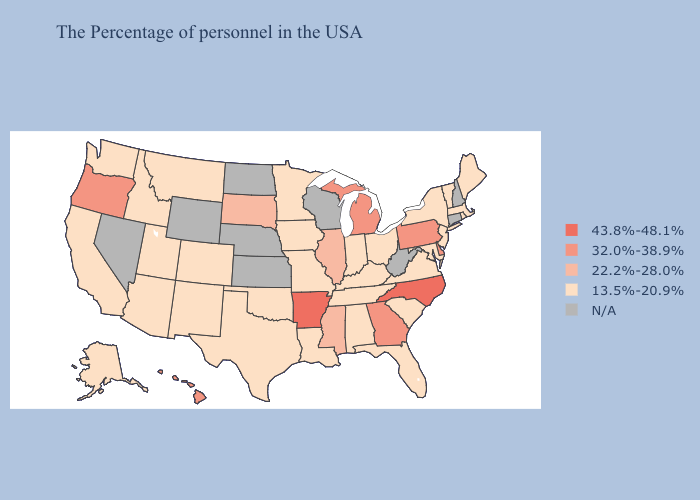Name the states that have a value in the range 43.8%-48.1%?
Write a very short answer. North Carolina, Arkansas. Does Hawaii have the highest value in the West?
Concise answer only. Yes. Does Idaho have the lowest value in the West?
Be succinct. Yes. What is the highest value in the USA?
Keep it brief. 43.8%-48.1%. What is the value of Montana?
Concise answer only. 13.5%-20.9%. What is the value of Maryland?
Be succinct. 13.5%-20.9%. What is the value of Louisiana?
Short answer required. 13.5%-20.9%. Does North Carolina have the lowest value in the South?
Give a very brief answer. No. Among the states that border New York , which have the lowest value?
Quick response, please. Massachusetts, Vermont, New Jersey. Is the legend a continuous bar?
Concise answer only. No. How many symbols are there in the legend?
Quick response, please. 5. Which states hav the highest value in the West?
Write a very short answer. Oregon, Hawaii. Is the legend a continuous bar?
Be succinct. No. 